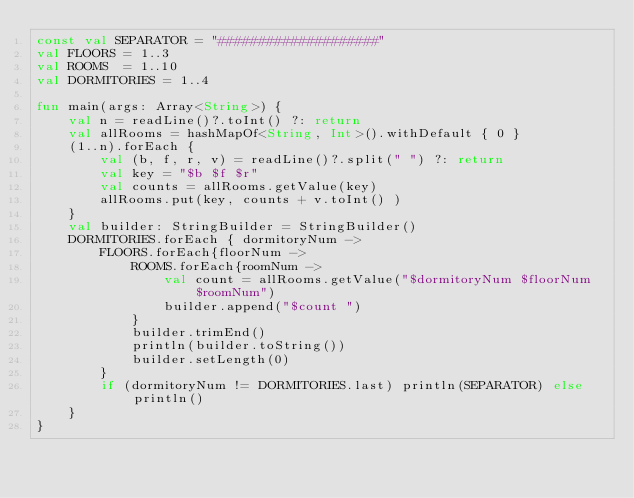<code> <loc_0><loc_0><loc_500><loc_500><_Kotlin_>const val SEPARATOR = "####################"
val FLOORS = 1..3
val ROOMS  = 1..10
val DORMITORIES = 1..4

fun main(args: Array<String>) {
    val n = readLine()?.toInt() ?: return
    val allRooms = hashMapOf<String, Int>().withDefault { 0 }
    (1..n).forEach {
        val (b, f, r, v) = readLine()?.split(" ") ?: return
        val key = "$b $f $r"
        val counts = allRooms.getValue(key)
        allRooms.put(key, counts + v.toInt() )
    }
    val builder: StringBuilder = StringBuilder()
    DORMITORIES.forEach { dormitoryNum ->
        FLOORS.forEach{floorNum ->
            ROOMS.forEach{roomNum ->
                val count = allRooms.getValue("$dormitoryNum $floorNum $roomNum")
                builder.append("$count ")
            }
            builder.trimEnd()
            println(builder.toString())
            builder.setLength(0)
        }
        if (dormitoryNum != DORMITORIES.last) println(SEPARATOR) else println()
    }
}
</code> 